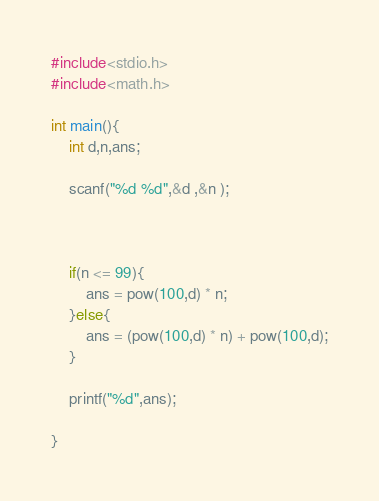<code> <loc_0><loc_0><loc_500><loc_500><_C_>#include<stdio.h>
#include<math.h>

int main(){
    int d,n,ans;

    scanf("%d %d",&d ,&n );



    if(n <= 99){
        ans = pow(100,d) * n;
    }else{
        ans = (pow(100,d) * n) + pow(100,d);
    }

    printf("%d",ans); 

}</code> 